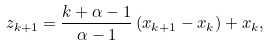Convert formula to latex. <formula><loc_0><loc_0><loc_500><loc_500>z _ { k + 1 } = \frac { k + \alpha - 1 } { \alpha - 1 } \left ( x _ { k + 1 } - x _ { k } \right ) + x _ { k } ,</formula> 